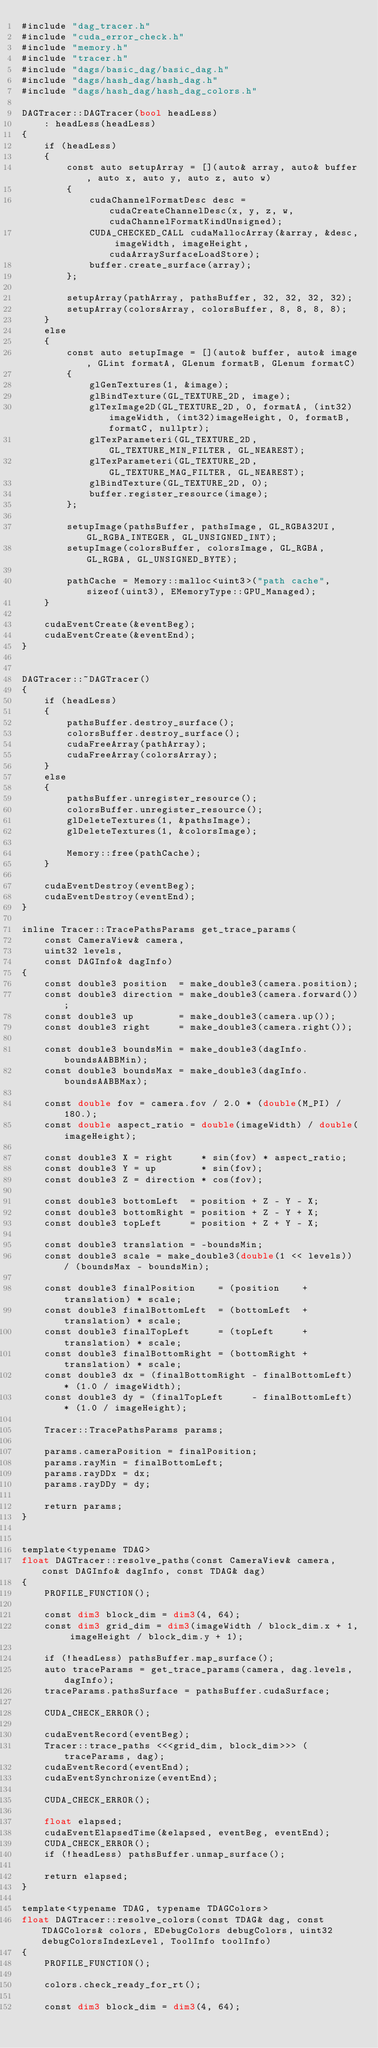Convert code to text. <code><loc_0><loc_0><loc_500><loc_500><_Cuda_>#include "dag_tracer.h"
#include "cuda_error_check.h"
#include "memory.h"
#include "tracer.h"
#include "dags/basic_dag/basic_dag.h"
#include "dags/hash_dag/hash_dag.h"
#include "dags/hash_dag/hash_dag_colors.h"

DAGTracer::DAGTracer(bool headLess)
	: headLess(headLess)
{
    if (headLess)
    {
        const auto setupArray = [](auto& array, auto& buffer, auto x, auto y, auto z, auto w)
        {
            cudaChannelFormatDesc desc = cudaCreateChannelDesc(x, y, z, w, cudaChannelFormatKindUnsigned);
            CUDA_CHECKED_CALL cudaMallocArray(&array, &desc, imageWidth, imageHeight, cudaArraySurfaceLoadStore);
            buffer.create_surface(array);
        };

        setupArray(pathArray, pathsBuffer, 32, 32, 32, 32);
        setupArray(colorsArray, colorsBuffer, 8, 8, 8, 8);
    }
    else
    {
        const auto setupImage = [](auto& buffer, auto& image, GLint formatA, GLenum formatB, GLenum formatC)
        {
            glGenTextures(1, &image);
            glBindTexture(GL_TEXTURE_2D, image);
            glTexImage2D(GL_TEXTURE_2D, 0, formatA, (int32)imageWidth, (int32)imageHeight, 0, formatB, formatC, nullptr);
            glTexParameteri(GL_TEXTURE_2D, GL_TEXTURE_MIN_FILTER, GL_NEAREST);
            glTexParameteri(GL_TEXTURE_2D, GL_TEXTURE_MAG_FILTER, GL_NEAREST);
            glBindTexture(GL_TEXTURE_2D, 0);
            buffer.register_resource(image);
        };

        setupImage(pathsBuffer, pathsImage, GL_RGBA32UI, GL_RGBA_INTEGER, GL_UNSIGNED_INT);
        setupImage(colorsBuffer, colorsImage, GL_RGBA, GL_RGBA, GL_UNSIGNED_BYTE);

        pathCache = Memory::malloc<uint3>("path cache", sizeof(uint3), EMemoryType::GPU_Managed);
    }

	cudaEventCreate(&eventBeg);
	cudaEventCreate(&eventEnd);
}


DAGTracer::~DAGTracer()
{
    if (headLess)
    {
		pathsBuffer.destroy_surface();
		colorsBuffer.destroy_surface();
		cudaFreeArray(pathArray);
		cudaFreeArray(colorsArray);
    }
    else
    {
        pathsBuffer.unregister_resource();
        colorsBuffer.unregister_resource();
        glDeleteTextures(1, &pathsImage);
        glDeleteTextures(1, &colorsImage);

        Memory::free(pathCache);
    }

	cudaEventDestroy(eventBeg);
	cudaEventDestroy(eventEnd);
}

inline Tracer::TracePathsParams get_trace_params(
	const CameraView& camera, 
	uint32 levels,
	const DAGInfo& dagInfo)
{
	const double3 position  = make_double3(camera.position);
	const double3 direction = make_double3(camera.forward());
	const double3 up        = make_double3(camera.up());
	const double3 right     = make_double3(camera.right());

	const double3 boundsMin = make_double3(dagInfo.boundsAABBMin);
	const double3 boundsMax = make_double3(dagInfo.boundsAABBMax);

	const double fov = camera.fov / 2.0 * (double(M_PI) / 180.);
	const double aspect_ratio = double(imageWidth) / double(imageHeight);
	
	const double3 X = right     * sin(fov) * aspect_ratio;
	const double3 Y = up        * sin(fov);
	const double3 Z = direction * cos(fov);

	const double3 bottomLeft  = position + Z - Y - X;
	const double3 bottomRight = position + Z - Y + X;
	const double3 topLeft     = position + Z + Y - X;

	const double3 translation = -boundsMin;
	const double3 scale = make_double3(double(1 << levels)) / (boundsMax - boundsMin);

	const double3 finalPosition    = (position    + translation) * scale;
	const double3 finalBottomLeft  = (bottomLeft  + translation) * scale;
	const double3 finalTopLeft     = (topLeft     + translation) * scale;
	const double3 finalBottomRight = (bottomRight + translation) * scale;
	const double3 dx = (finalBottomRight - finalBottomLeft) * (1.0 / imageWidth);
	const double3 dy = (finalTopLeft     - finalBottomLeft) * (1.0 / imageHeight);

	Tracer::TracePathsParams params;

	params.cameraPosition = finalPosition;
	params.rayMin = finalBottomLeft;
	params.rayDDx = dx;
	params.rayDDy = dy;

	return params;
}


template<typename TDAG>
float DAGTracer::resolve_paths(const CameraView& camera, const DAGInfo& dagInfo, const TDAG& dag)
{
	PROFILE_FUNCTION();
	
	const dim3 block_dim = dim3(4, 64);
	const dim3 grid_dim = dim3(imageWidth / block_dim.x + 1, imageHeight / block_dim.y + 1);

    if (!headLess) pathsBuffer.map_surface();
	auto traceParams = get_trace_params(camera, dag.levels, dagInfo);
	traceParams.pathsSurface = pathsBuffer.cudaSurface;

    CUDA_CHECK_ERROR();

	cudaEventRecord(eventBeg);
	Tracer::trace_paths <<<grid_dim, block_dim>>> (traceParams, dag);
	cudaEventRecord(eventEnd);
	cudaEventSynchronize(eventEnd);

	CUDA_CHECK_ERROR();

	float elapsed;
	cudaEventElapsedTime(&elapsed, eventBeg, eventEnd);
	CUDA_CHECK_ERROR();
	if (!headLess) pathsBuffer.unmap_surface();

	return elapsed;
}

template<typename TDAG, typename TDAGColors>
float DAGTracer::resolve_colors(const TDAG& dag, const TDAGColors& colors, EDebugColors debugColors, uint32 debugColorsIndexLevel, ToolInfo toolInfo)
{
	PROFILE_FUNCTION();
	
    colors.check_ready_for_rt();

	const dim3 block_dim = dim3(4, 64);</code> 